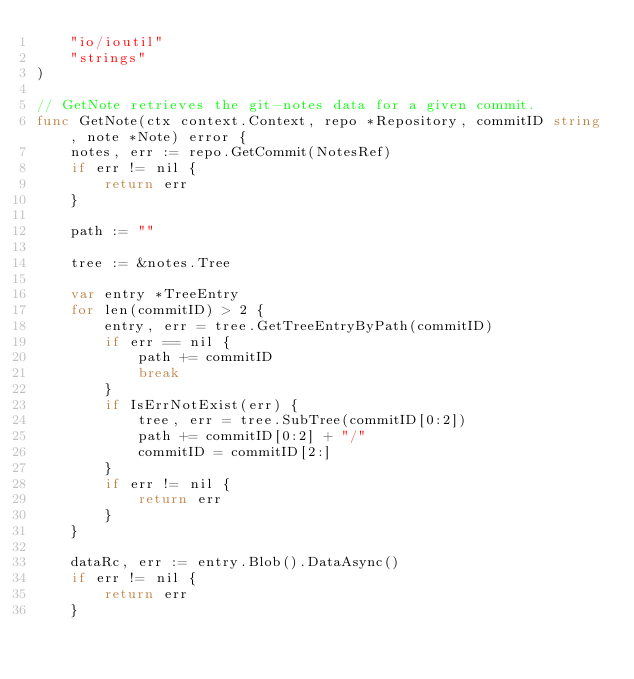<code> <loc_0><loc_0><loc_500><loc_500><_Go_>	"io/ioutil"
	"strings"
)

// GetNote retrieves the git-notes data for a given commit.
func GetNote(ctx context.Context, repo *Repository, commitID string, note *Note) error {
	notes, err := repo.GetCommit(NotesRef)
	if err != nil {
		return err
	}

	path := ""

	tree := &notes.Tree

	var entry *TreeEntry
	for len(commitID) > 2 {
		entry, err = tree.GetTreeEntryByPath(commitID)
		if err == nil {
			path += commitID
			break
		}
		if IsErrNotExist(err) {
			tree, err = tree.SubTree(commitID[0:2])
			path += commitID[0:2] + "/"
			commitID = commitID[2:]
		}
		if err != nil {
			return err
		}
	}

	dataRc, err := entry.Blob().DataAsync()
	if err != nil {
		return err
	}</code> 